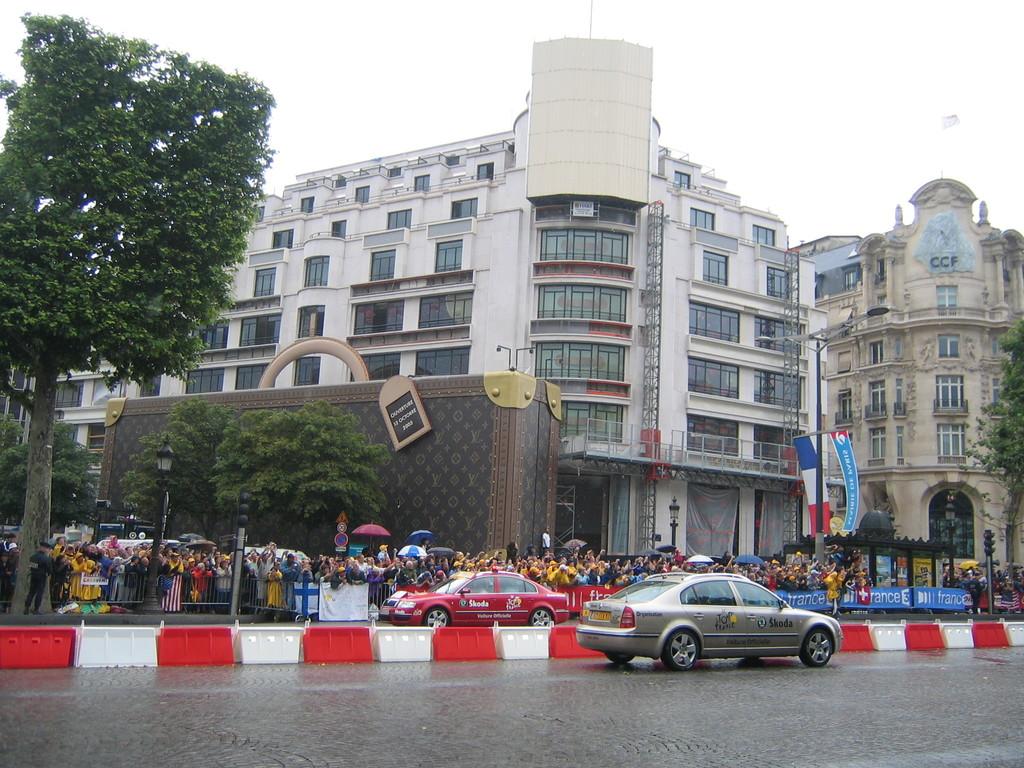What does the car say?
Keep it short and to the point. Skoda. What letters are displayed on the top floor of the building on the right?
Give a very brief answer. Ccf. 